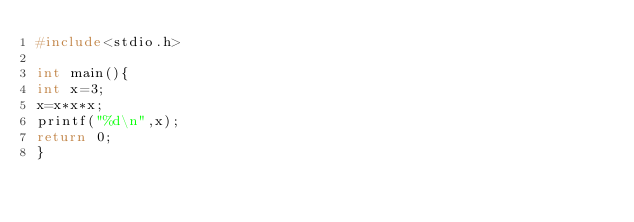Convert code to text. <code><loc_0><loc_0><loc_500><loc_500><_C_>#include<stdio.h>

int main(){
int x=3;
x=x*x*x;
printf("%d\n",x);
return 0;
}</code> 